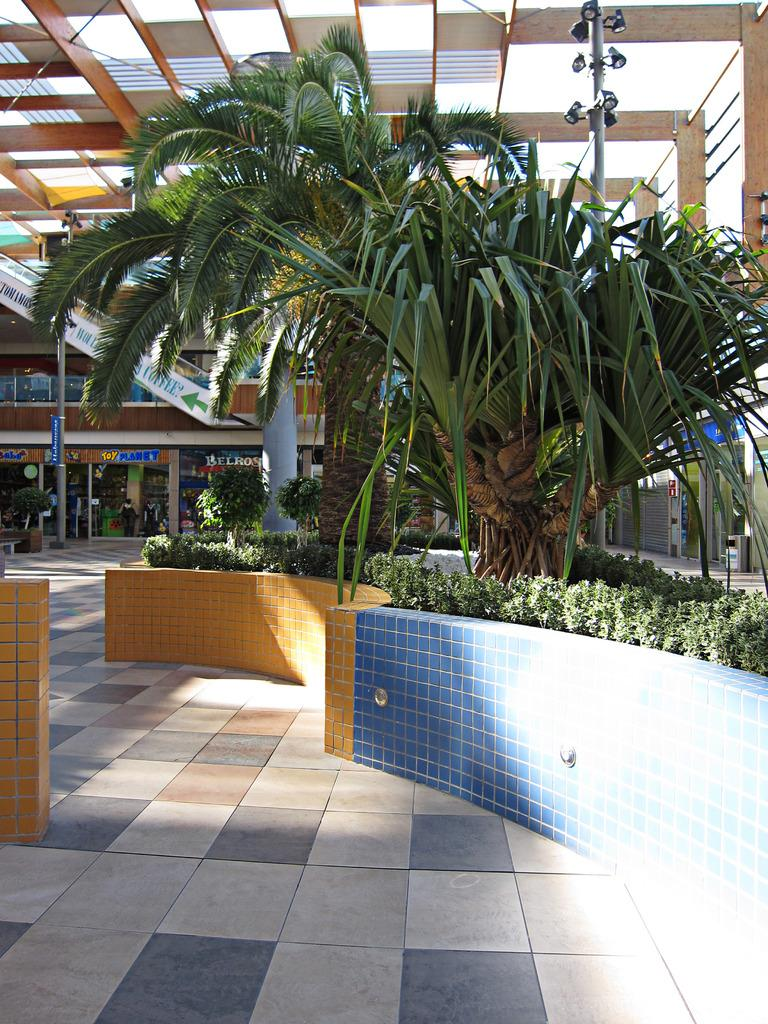What type of establishments can be seen in the image? There are stores in the image. What natural elements are present in the image? There are two trees and many plants in the image. What object is used for waste disposal in the image? There is a dustbin in the image. What structure is present in the image for supporting objects? There is a pole in the image. What are the lamps connected to in the image? The lamps are connected to the pole in the image. Can you see any fingers holding a berry in the image? There are no fingers or berries present in the image. What type of trade is being conducted in the image? There is no trade being conducted in the image; it primarily features stores, trees, plants, a dustbin, a pole, and lamps. 